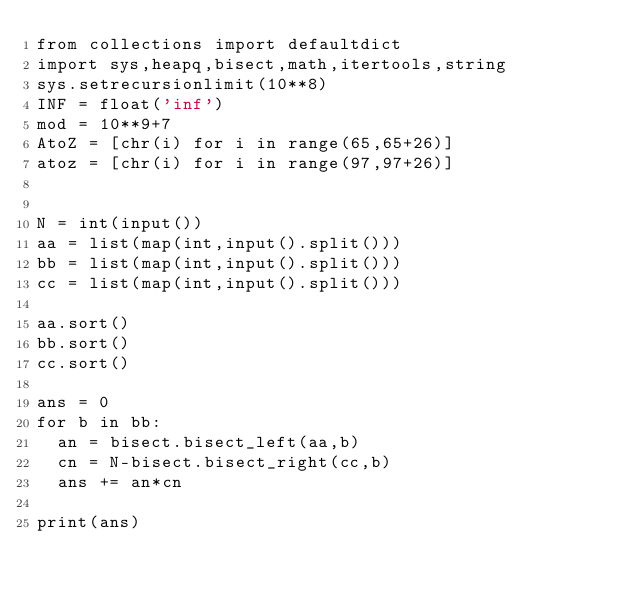Convert code to text. <code><loc_0><loc_0><loc_500><loc_500><_Python_>from collections import defaultdict
import sys,heapq,bisect,math,itertools,string
sys.setrecursionlimit(10**8)
INF = float('inf')
mod = 10**9+7
AtoZ = [chr(i) for i in range(65,65+26)]
atoz = [chr(i) for i in range(97,97+26)]


N = int(input())
aa = list(map(int,input().split()))
bb = list(map(int,input().split()))
cc = list(map(int,input().split()))

aa.sort()
bb.sort()
cc.sort()

ans = 0
for b in bb:
	an = bisect.bisect_left(aa,b)
	cn = N-bisect.bisect_right(cc,b)
	ans += an*cn

print(ans)
</code> 